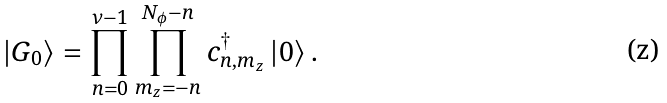Convert formula to latex. <formula><loc_0><loc_0><loc_500><loc_500>\left | G _ { 0 } \right \rangle = \prod _ { n = 0 } ^ { \nu - 1 } \prod _ { m _ { z } = - n } ^ { N _ { \phi } - n } c _ { n , m _ { z } } ^ { \dagger } \left | 0 \right \rangle .</formula> 